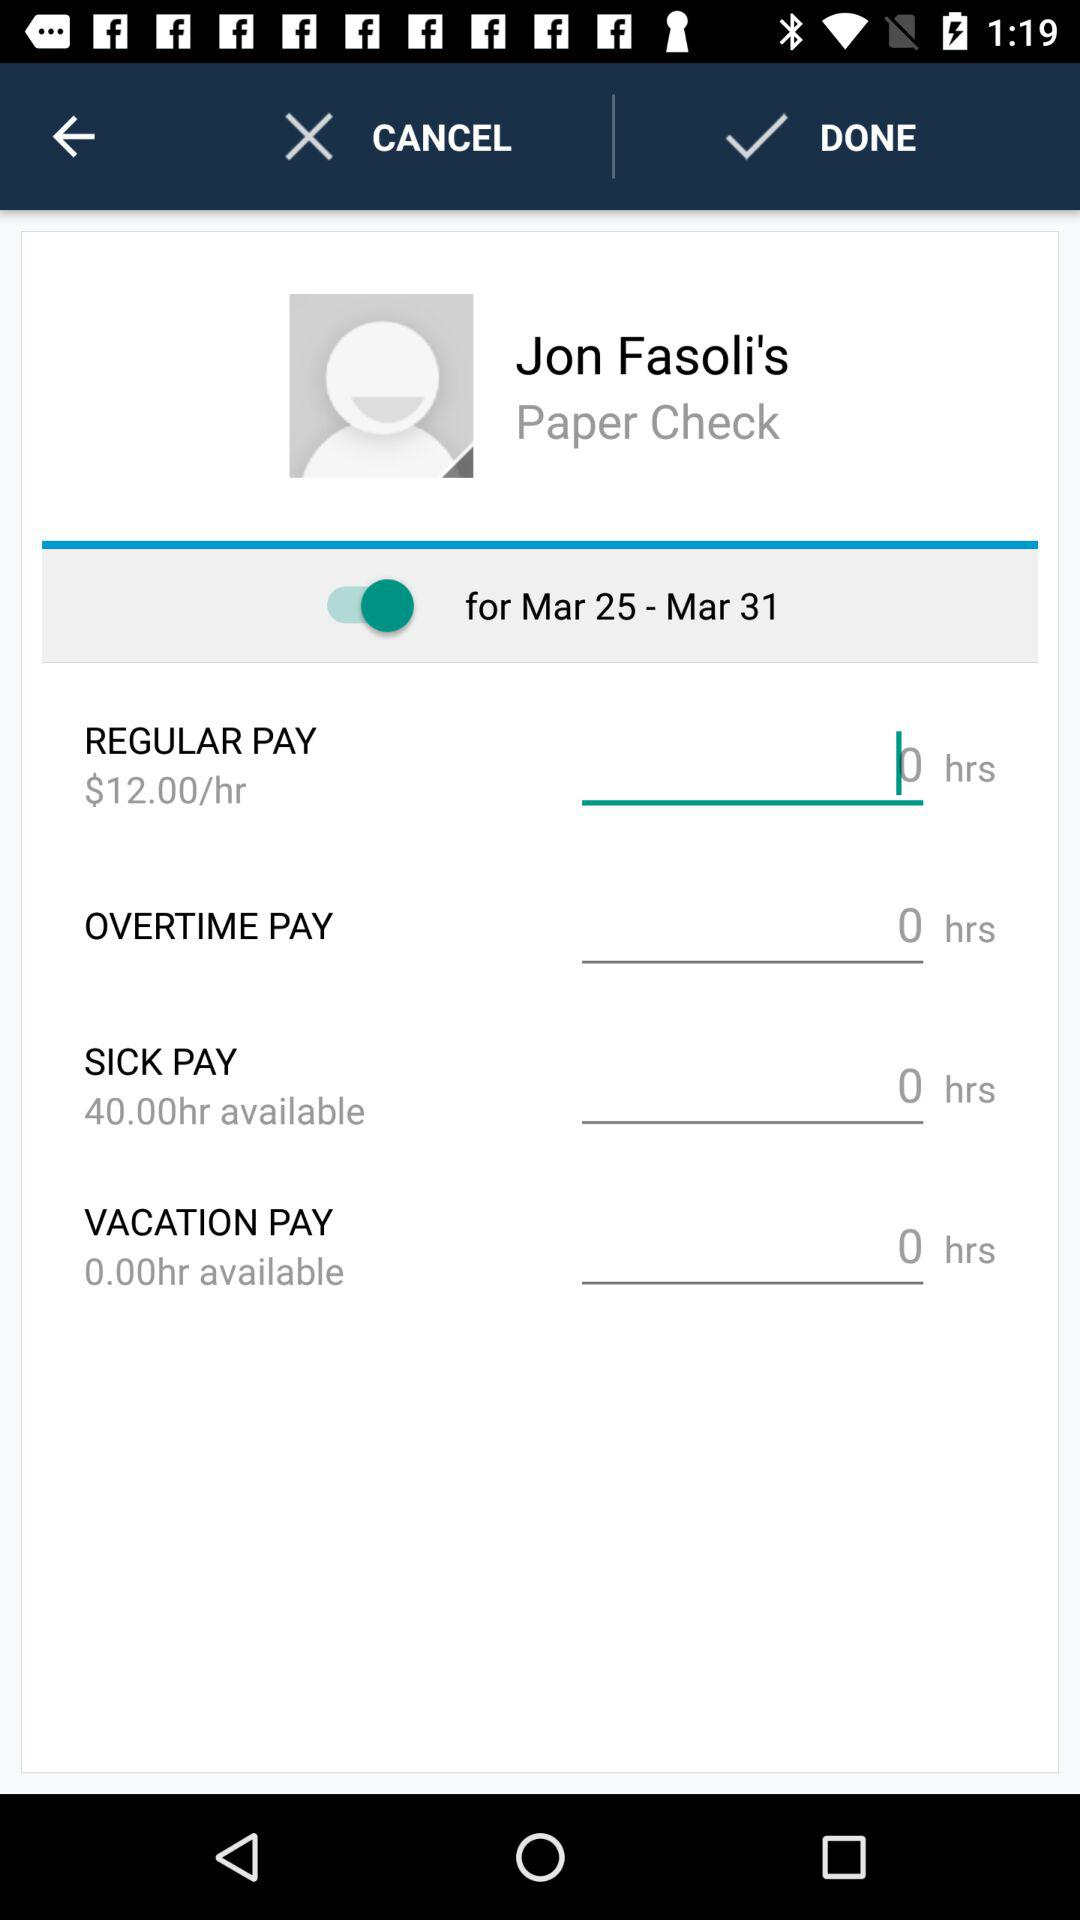What will they charge for a sick day?
When the provided information is insufficient, respond with <no answer>. <no answer> 